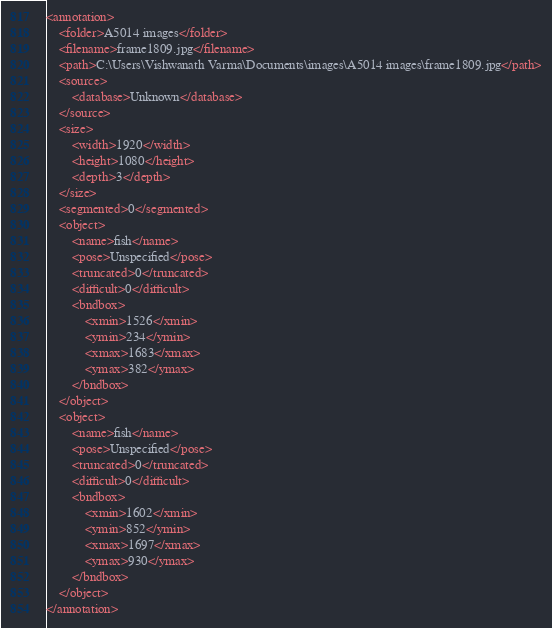Convert code to text. <code><loc_0><loc_0><loc_500><loc_500><_XML_><annotation>
	<folder>A5014 images</folder>
	<filename>frame1809.jpg</filename>
	<path>C:\Users\Vishwanath Varma\Documents\images\A5014 images\frame1809.jpg</path>
	<source>
		<database>Unknown</database>
	</source>
	<size>
		<width>1920</width>
		<height>1080</height>
		<depth>3</depth>
	</size>
	<segmented>0</segmented>
	<object>
		<name>fish</name>
		<pose>Unspecified</pose>
		<truncated>0</truncated>
		<difficult>0</difficult>
		<bndbox>
			<xmin>1526</xmin>
			<ymin>234</ymin>
			<xmax>1683</xmax>
			<ymax>382</ymax>
		</bndbox>
	</object>
	<object>
		<name>fish</name>
		<pose>Unspecified</pose>
		<truncated>0</truncated>
		<difficult>0</difficult>
		<bndbox>
			<xmin>1602</xmin>
			<ymin>852</ymin>
			<xmax>1697</xmax>
			<ymax>930</ymax>
		</bndbox>
	</object>
</annotation>
</code> 